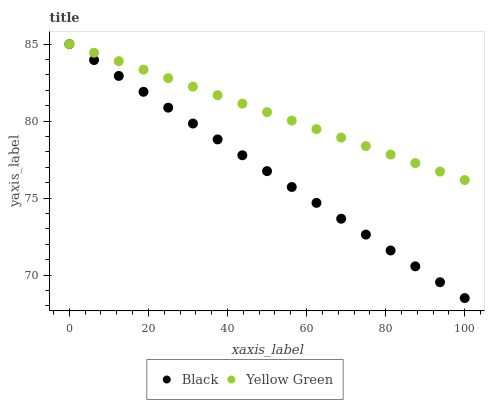Does Black have the minimum area under the curve?
Answer yes or no. Yes. Does Yellow Green have the maximum area under the curve?
Answer yes or no. Yes. Does Yellow Green have the minimum area under the curve?
Answer yes or no. No. Is Yellow Green the smoothest?
Answer yes or no. Yes. Is Black the roughest?
Answer yes or no. Yes. Is Yellow Green the roughest?
Answer yes or no. No. Does Black have the lowest value?
Answer yes or no. Yes. Does Yellow Green have the lowest value?
Answer yes or no. No. Does Yellow Green have the highest value?
Answer yes or no. Yes. Does Black intersect Yellow Green?
Answer yes or no. Yes. Is Black less than Yellow Green?
Answer yes or no. No. Is Black greater than Yellow Green?
Answer yes or no. No. 